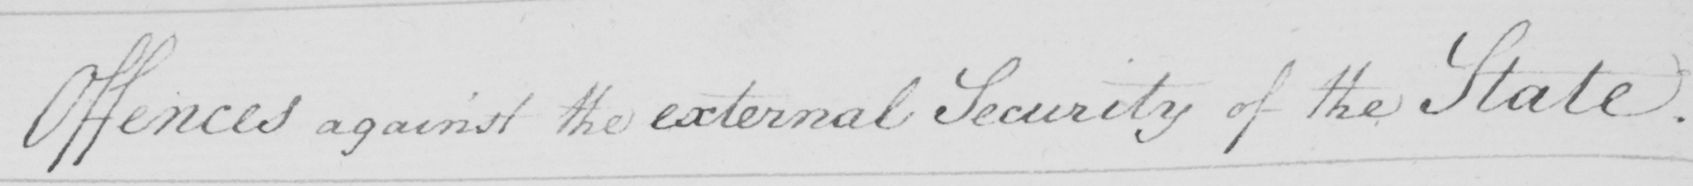What does this handwritten line say? Offences against the external Security of the State 